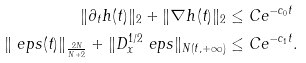<formula> <loc_0><loc_0><loc_500><loc_500>\| \partial _ { t } h ( t ) \| _ { 2 } + \| \nabla h ( t ) \| _ { 2 } & \leq C e ^ { - c _ { 0 } t } \\ \| \ e p s ( t ) \| _ { \frac { 2 N } { N + 2 } } + \| D _ { x } ^ { 1 / 2 } \ e p s \| _ { N ( t , + \infty ) } & \leq C e ^ { - c _ { 1 } t } .</formula> 